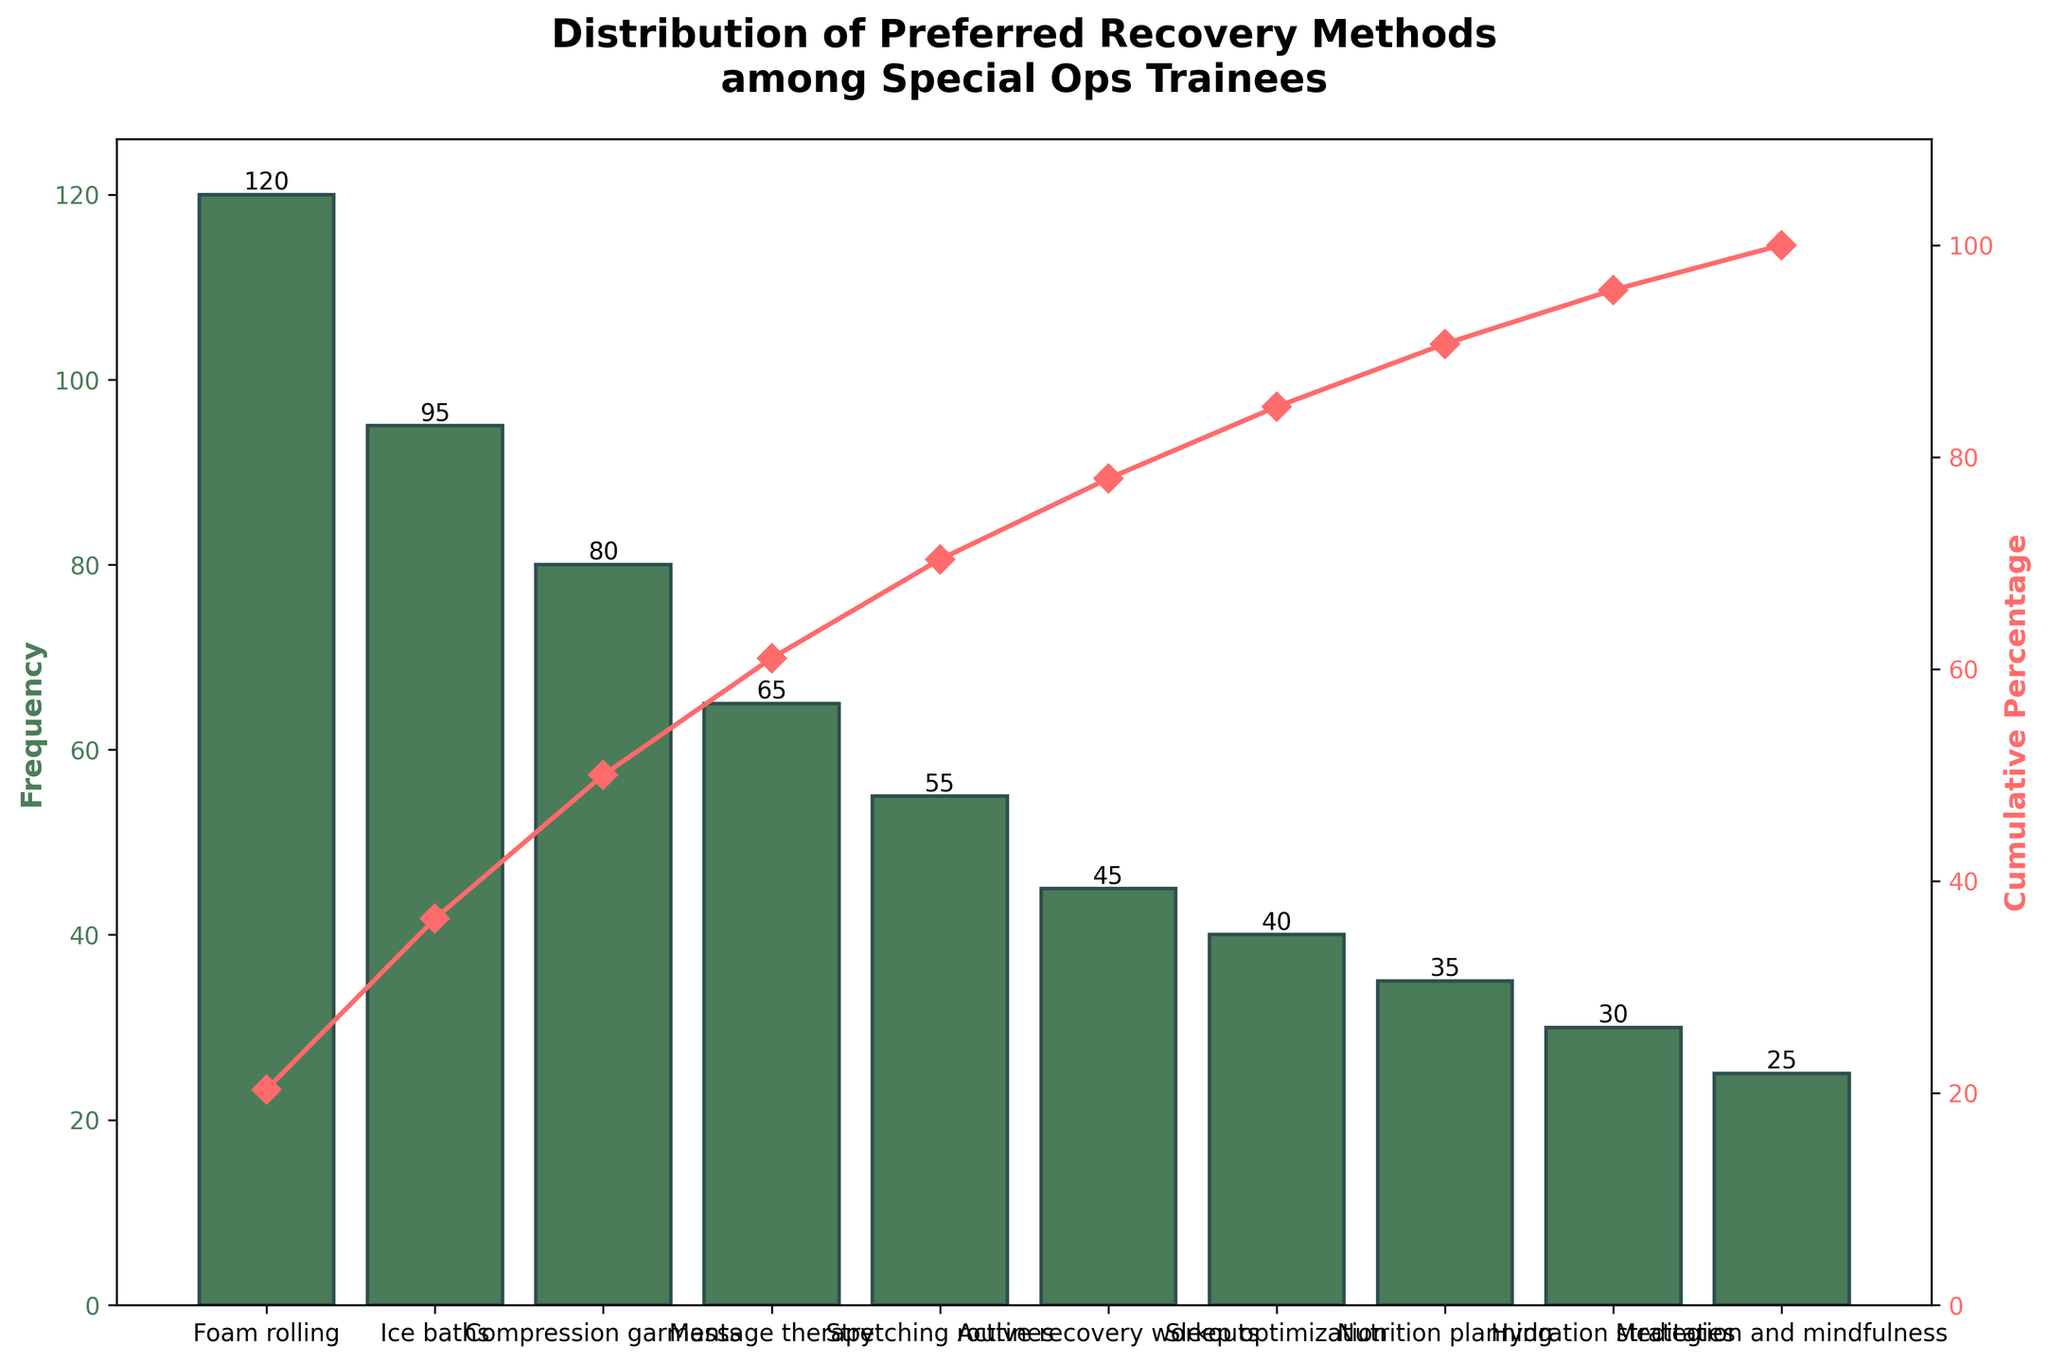What is the title of the figure? The title of the figure is located at the top and usually summarizes what the chart represents.
Answer: Distribution of Preferred Recovery Methods among Special Ops Trainees Which recovery method has the highest frequency? The recovery method with the tallest bar represents the highest frequency.
Answer: Foam rolling How many recovery methods have a frequency greater than or equal to 50? Count the number of bars with heights that are 50 or greater.
Answer: Five methods What is the cumulative percentage for the 'Compression garments' recovery method? Find the data point corresponding to 'Compression garments' and locate the cumulative percentage line intersection.
Answer: Approximately 70% How does the cumulative percentage curve trend from 'Compression garments' to 'Meditation and mindfulness'? Observe the slope of the line connecting 'Compression garments' to 'Meditation and mindfulness'. It shows how cumulative percentage increases.
Answer: Steadily increases What is the difference in frequency between 'Foam rolling' and 'Meditation and mindfulness'? Subtract the frequency of 'Meditation and mindfulness' from 'Foam rolling'.
Answer: 95 What recovery methods contribute to the first 50% of the cumulative percentage? Identify the recovery methods whose cumulative percentage reaches 50%.
Answer: Foam rolling, Ice baths, Compression garments Which recovery method shows the smallest frequency on the chart? Find the shortest bar on the chart.
Answer: Meditation and mindfulness 